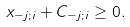<formula> <loc_0><loc_0><loc_500><loc_500>x _ { - j ; i } + C _ { - j ; i } \geq 0 .</formula> 